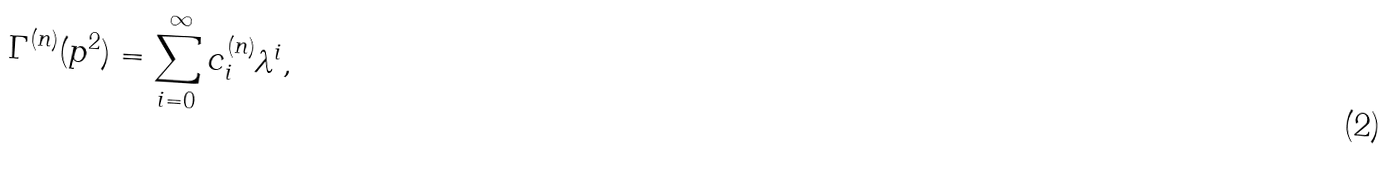<formula> <loc_0><loc_0><loc_500><loc_500>\Gamma ^ { ( n ) } ( p ^ { 2 } ) = \sum _ { i = 0 } ^ { \infty } c _ { i } ^ { ( n ) } \lambda ^ { i } ,</formula> 